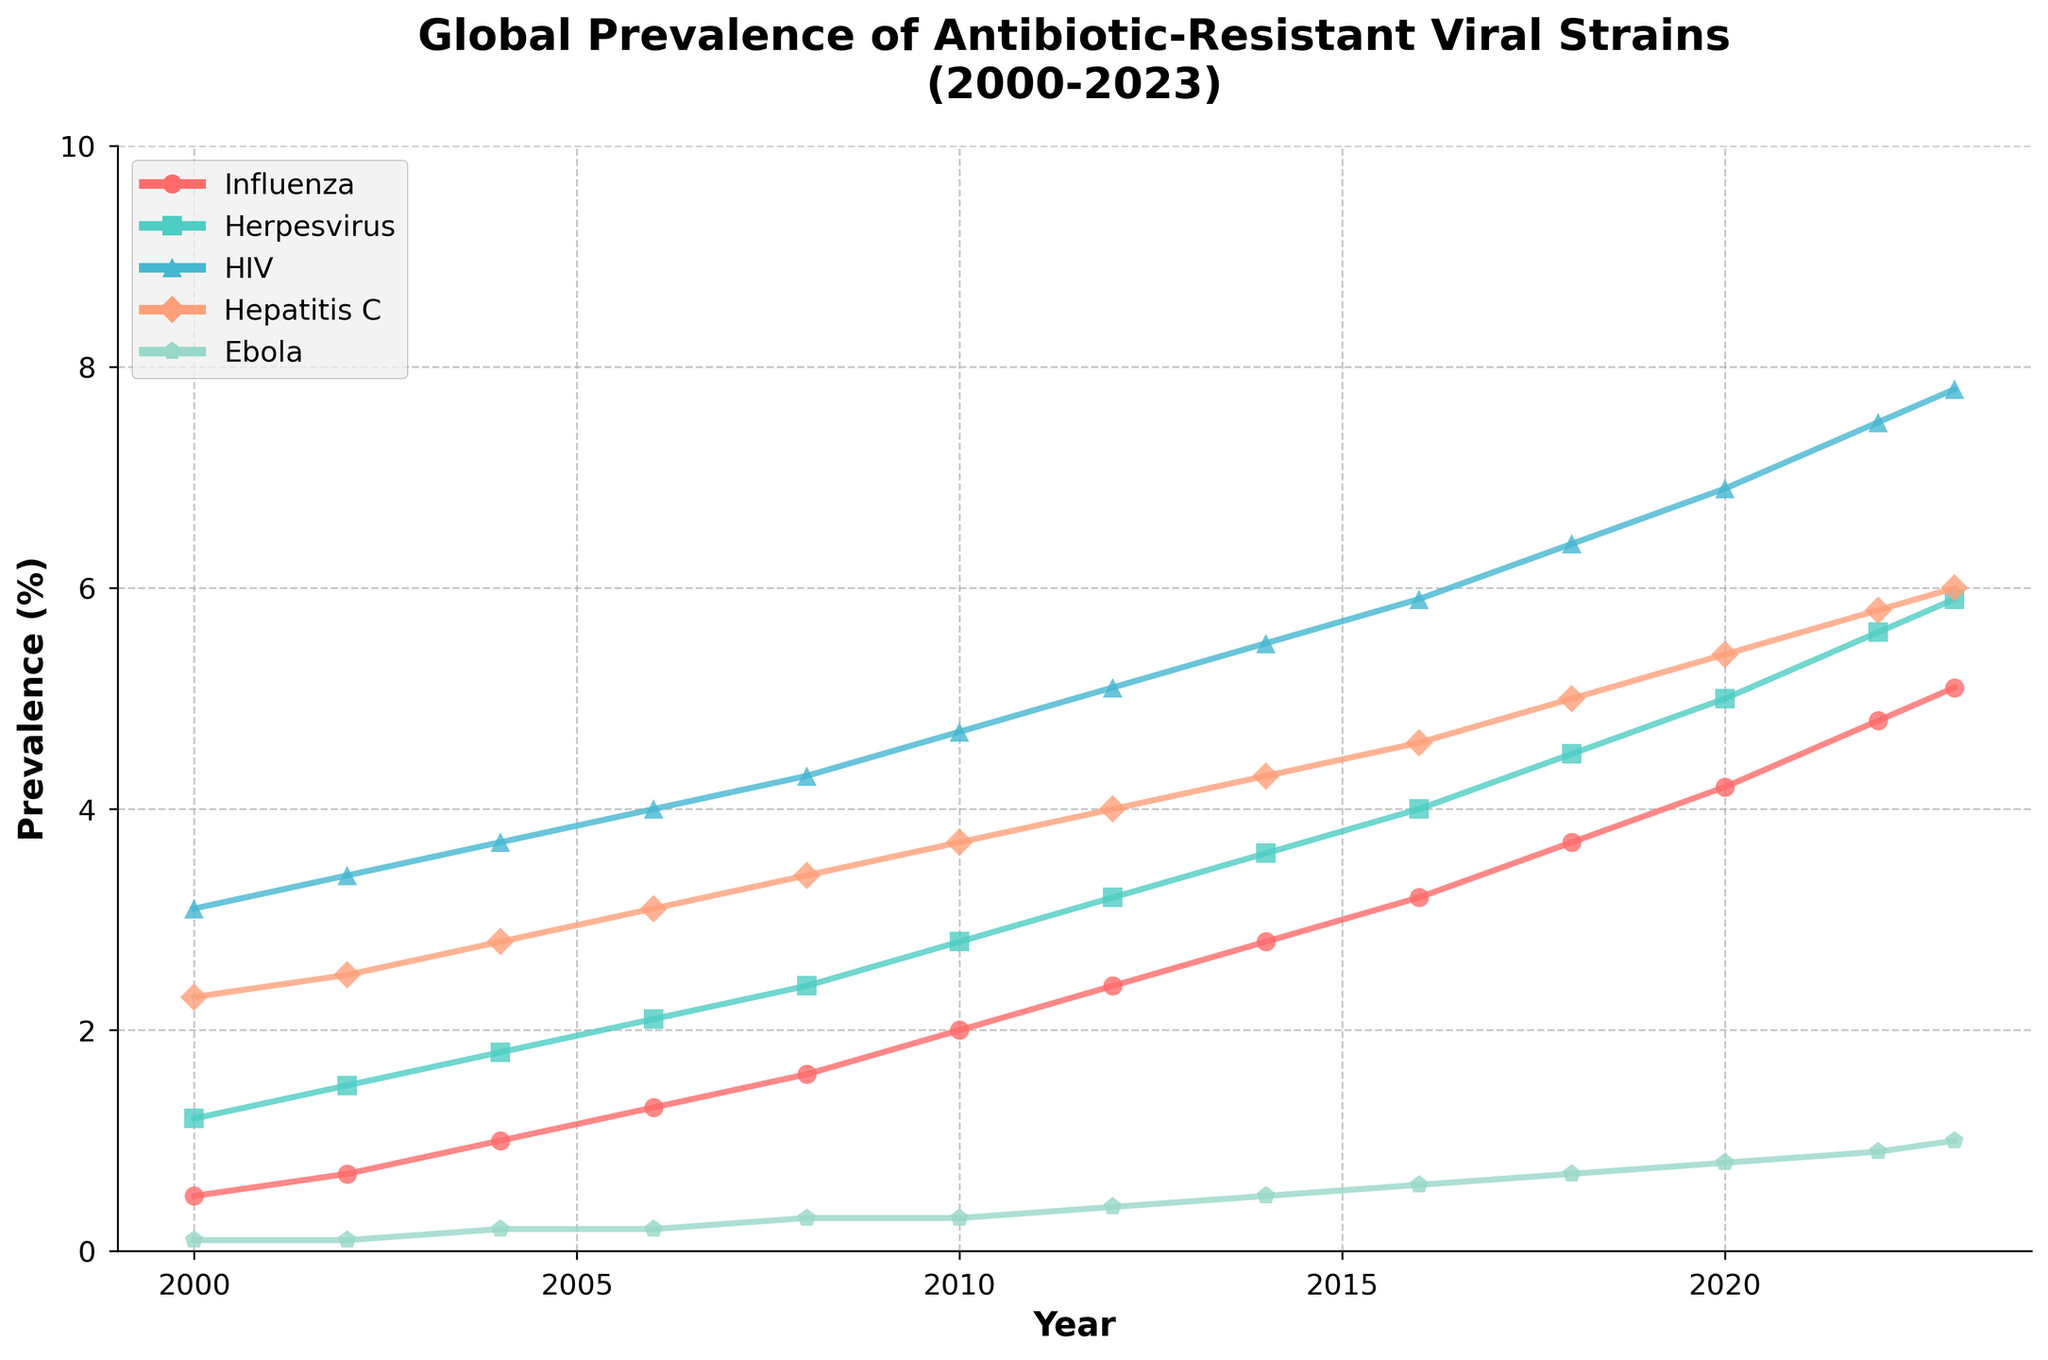What’s the overall trend for the prevalence of antibiotic-resistant influenza from 2000 to 2023? The figure shows a gradual increase in the prevalence of antibiotic-resistant influenza over the years. In 2000, the prevalence was at 0.5%, and it steadily rises to 5.1% by 2023.
Answer: Increasing Which viral strain exhibits the highest prevalence in 2023? By examining the end of each line chart, we can see that HIV has the highest prevalence in 2023, reaching 7.8%.
Answer: HIV Compare the prevalence of antibiotic-resistant influenza and Ebola in 2020. How many times higher is influenza compared to Ebola? According to the figure, in 2020, the prevalence of antibiotic-resistant influenza is 4.2%, while Ebola is at 0.8%. Hence, influenza prevalence is 4.2 / 0.8 = 5.25 times higher than Ebola.
Answer: 5.25 times What is the difference in the prevalence of antibiotic-resistant Hepatitis C between 2002 and 2023? In the figure, the prevalence of Hepatitis C in 2002 is 2.5%, and in 2023 it is 6.0%. The difference is 6.0% - 2.5% = 3.5%.
Answer: 3.5% During which period did Herpesvirus exhibit the most significant increase in prevalence? Observing the slope of the Herpesvirus line, the steepest increase occurs between 2010 and 2012, where it jumps from 2.8% to 3.2%, a 0.4% increase over two years.
Answer: 2010-2012 What visual attribute signifies that HIV has had the highest prevalence almost throughout the years? HIV's line is consistently the highest across the plotted years, visually indicating it has the most significant values among all viral strains.
Answer: Highest line Which year marks the first instance when the prevalence of Ebola exceeded 0.5%? According to the figure, in 2014, the prevalence of Ebola first reaches 0.5%.
Answer: 2014 What is the combined prevalence of antibiotic-resistant viral strains, excluding Ebola, in 2018? In 2018, the prevalence values are: Influenza: 3.7%, Herpesvirus: 4.5%, HIV: 6.4%, Hepatitis C: 5.0%. Adding these gives 3.7 + 4.5 + 6.4 + 5.0 = 19.6%.
Answer: 19.6% In which year did the prevalence of antibiotic-resistant Herpesvirus surpass 4%? The figure shows that Herpesvirus surpasses 4% in the year 2016.
Answer: 2016 By how much did the prevalence of antibiotic-resistant Ebola increase between 2000 and 2023? The figure indicates that Ebola's prevalence increased from 0.1% in 2000 to 1.0% in 2023. The increase is 1.0% - 0.1% = 0.9%.
Answer: 0.9% 